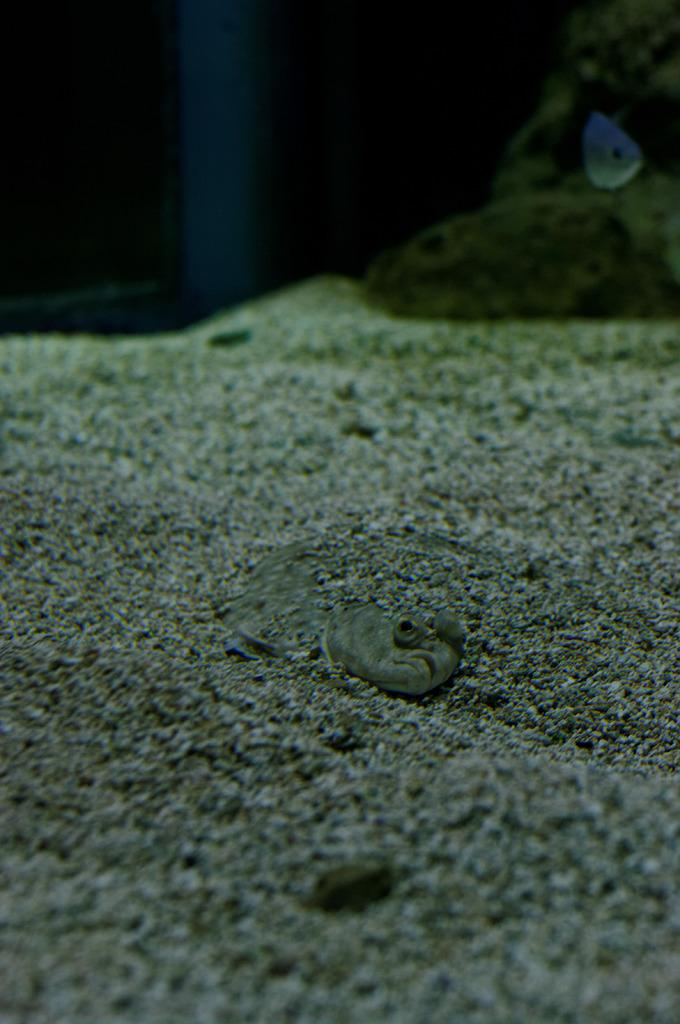What type of terrain is visible in the image? There is sand in the image. What type of animal can be seen in the image? There is a reptile in the image that resembles a snake. Can you describe the background of the image? The background of the image is blurred. What type of wax can be seen melting in the image? There is no wax present in the image. Where is the drawer located in the image? There is no drawer present in the image. 